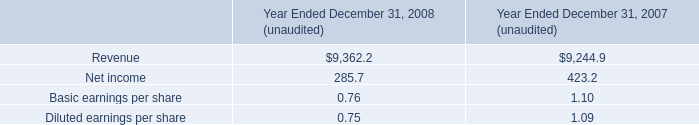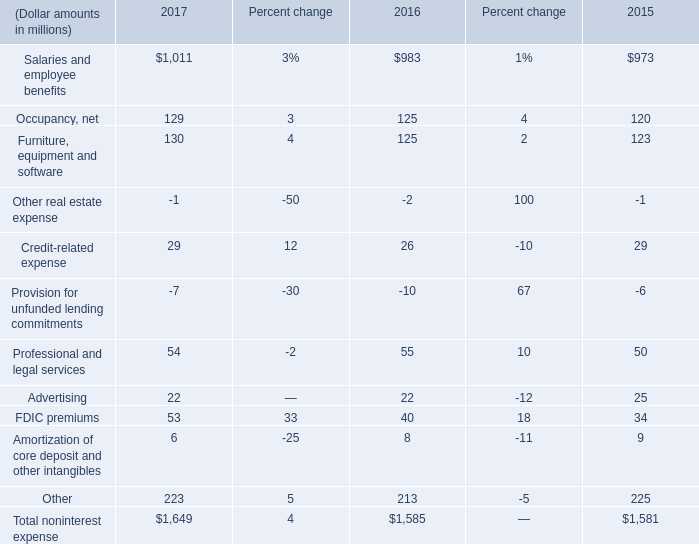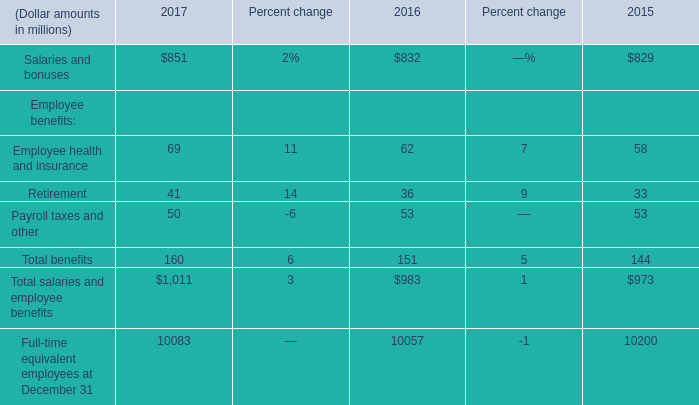What is the difference between 2017 and 2016 's highest employee benefits? (in million) 
Computations: (69 - 62)
Answer: 7.0. 